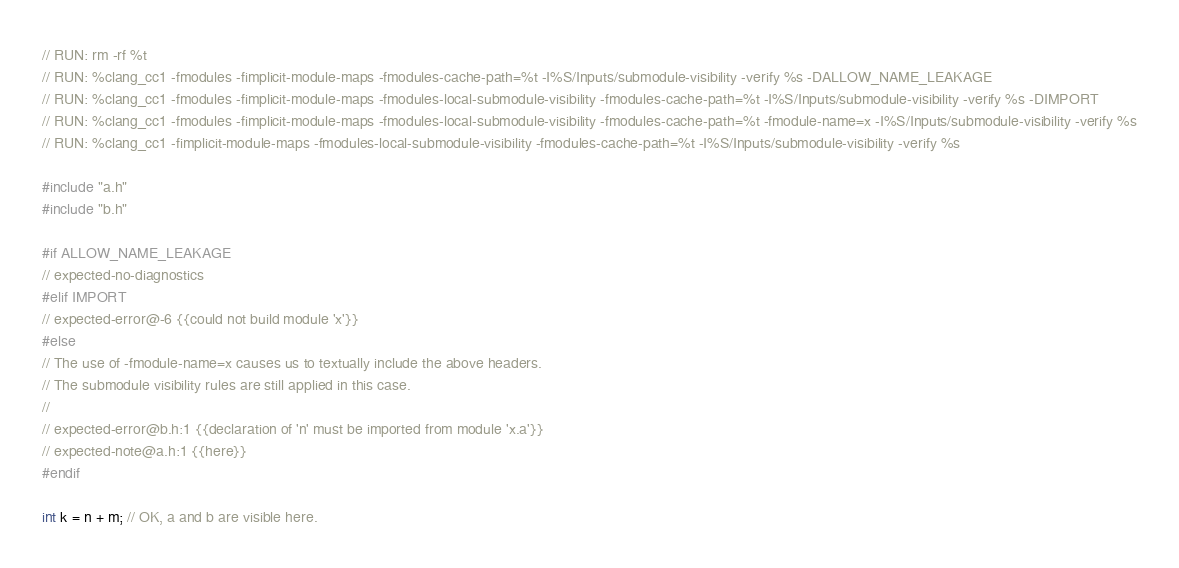<code> <loc_0><loc_0><loc_500><loc_500><_C++_>// RUN: rm -rf %t
// RUN: %clang_cc1 -fmodules -fimplicit-module-maps -fmodules-cache-path=%t -I%S/Inputs/submodule-visibility -verify %s -DALLOW_NAME_LEAKAGE
// RUN: %clang_cc1 -fmodules -fimplicit-module-maps -fmodules-local-submodule-visibility -fmodules-cache-path=%t -I%S/Inputs/submodule-visibility -verify %s -DIMPORT
// RUN: %clang_cc1 -fmodules -fimplicit-module-maps -fmodules-local-submodule-visibility -fmodules-cache-path=%t -fmodule-name=x -I%S/Inputs/submodule-visibility -verify %s
// RUN: %clang_cc1 -fimplicit-module-maps -fmodules-local-submodule-visibility -fmodules-cache-path=%t -I%S/Inputs/submodule-visibility -verify %s

#include "a.h"
#include "b.h"

#if ALLOW_NAME_LEAKAGE
// expected-no-diagnostics
#elif IMPORT
// expected-error@-6 {{could not build module 'x'}}
#else
// The use of -fmodule-name=x causes us to textually include the above headers.
// The submodule visibility rules are still applied in this case.
//
// expected-error@b.h:1 {{declaration of 'n' must be imported from module 'x.a'}}
// expected-note@a.h:1 {{here}}
#endif

int k = n + m; // OK, a and b are visible here.
</code> 